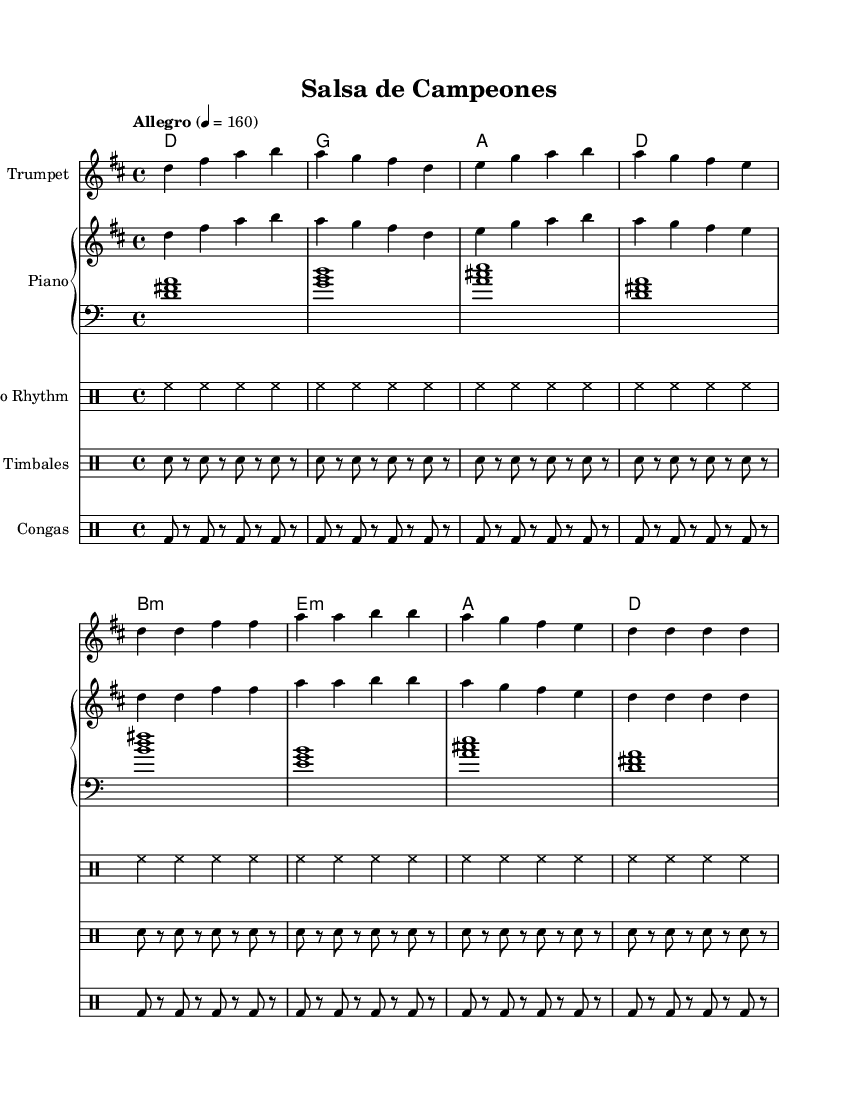What is the key signature of this music? The key signature is D major, which includes two sharps: F# and C#. This is determined by looking at the key signature indicated at the beginning of the score.
Answer: D major What is the time signature of this music? The time signature is 4/4, indicated at the beginning of the score. This means there are four beats in each measure, and the quarter note receives one beat.
Answer: 4/4 What is the tempo marking for this piece? The tempo marking is "Allegro," which indicates a fast and lively pace. This is specified next to the tempo indication in the score, along with a metronome mark of 160 beats per minute.
Answer: Allegro How many measures are in the main theme? The main theme consists of four measures, as shown in the melody section. The melody is clearly divided into sections, with the first part containing four distinct measures.
Answer: 4 Which instrument plays the melody? The melody is played by the Trumpet, as indicated by the instrument name at the beginning of the staff within the score. The Trumpet is typically used to carry the main melodic line in salsa music.
Answer: Trumpet What rhythmic pattern do the congas play? The congas have a repeating pattern of bass drum strokes alternating with rests. This is derived from the drummode section in the score where the conga rhythms are specified.
Answer: bass drum with rests What type of musical form is prominent in Latin music like this? The music features a call-and-response form, a common characteristic in Latin music, where the melody often alternates between a lead instrument and responses from other instruments or vocal lines. This is inferred from traditional structuring in salsa and similar genres.
Answer: Call-and-response 